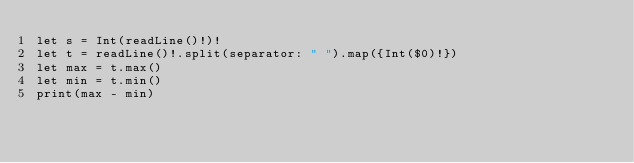Convert code to text. <code><loc_0><loc_0><loc_500><loc_500><_Swift_>let s = Int(readLine()!)!
let t = readLine()!.split(separator: " ").map({Int($0)!})
let max = t.max()
let min = t.min()
print(max - min)</code> 